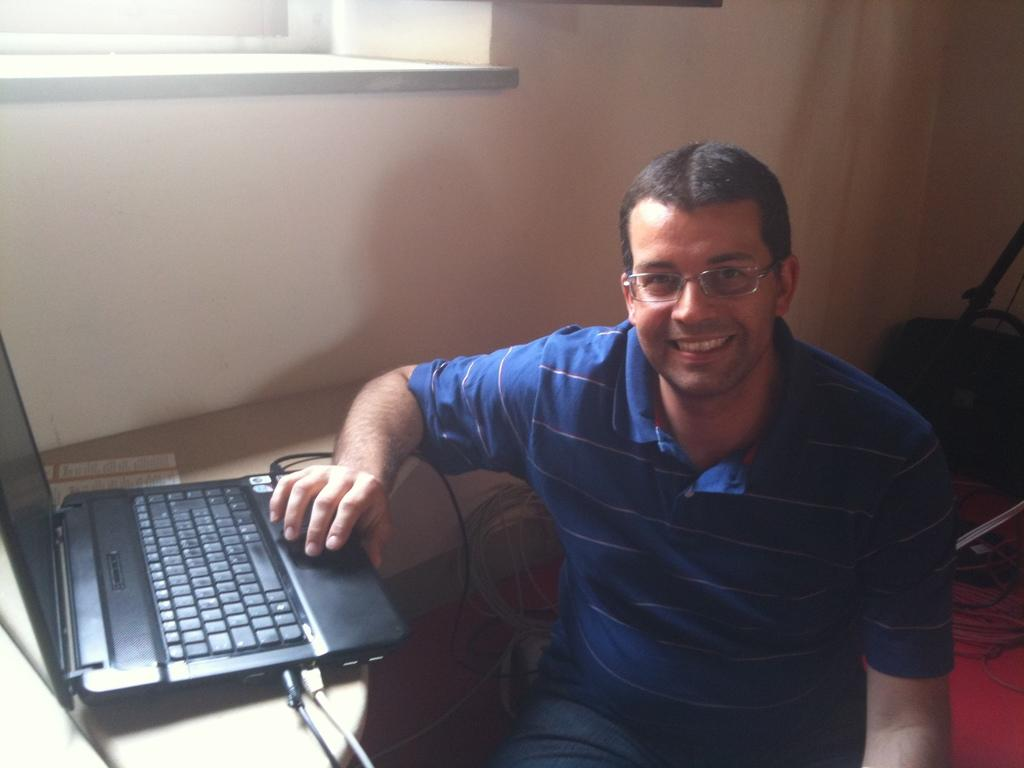Who is present in the image? There is a man in the picture. What is the man doing in the image? The man is seated and smiling. What object is the man holding in the image? The man is holding a laptop. Where is the laptop placed in the image? The laptop is on a table. What type of skate is the man using to balance the laptop in the image? There is no skate present in the image, and the man is not using any object to balance the laptop. 